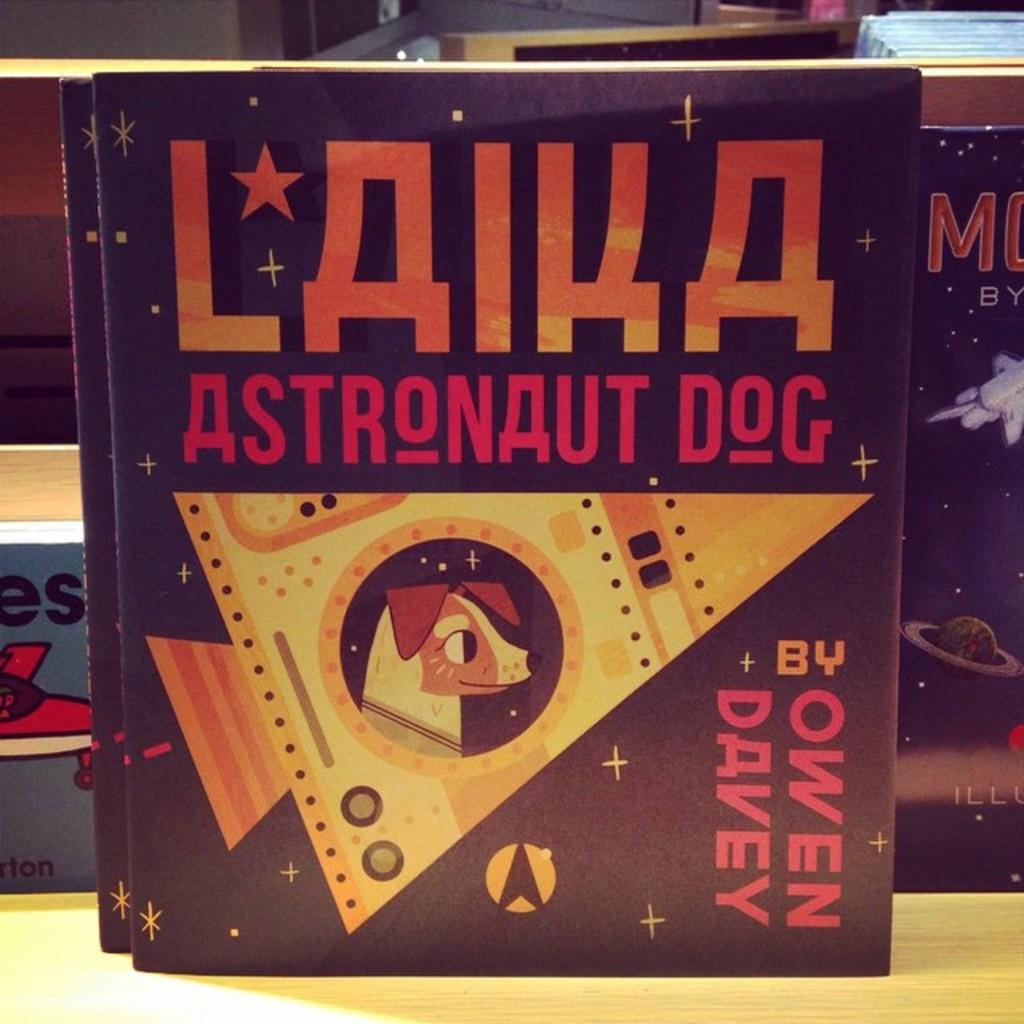Who wrote this book?
Make the answer very short. Owen davey. What animal is on the book?
Offer a terse response. Dog. 